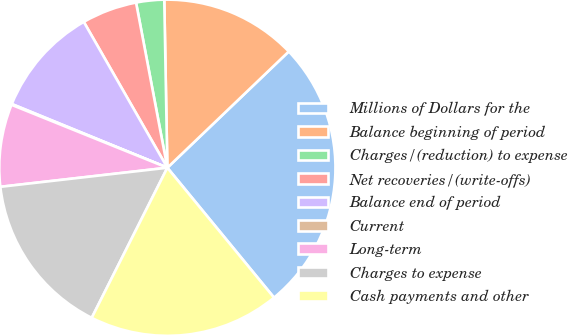<chart> <loc_0><loc_0><loc_500><loc_500><pie_chart><fcel>Millions of Dollars for the<fcel>Balance beginning of period<fcel>Charges/(reduction) to expense<fcel>Net recoveries/(write-offs)<fcel>Balance end of period<fcel>Current<fcel>Long-term<fcel>Charges to expense<fcel>Cash payments and other<nl><fcel>26.21%<fcel>13.14%<fcel>2.69%<fcel>5.3%<fcel>10.53%<fcel>0.08%<fcel>7.92%<fcel>15.76%<fcel>18.37%<nl></chart> 